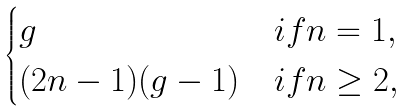Convert formula to latex. <formula><loc_0><loc_0><loc_500><loc_500>\begin{cases} g & i f n = 1 , \\ ( 2 n - 1 ) ( g - 1 ) & i f n \geq 2 , \end{cases}</formula> 